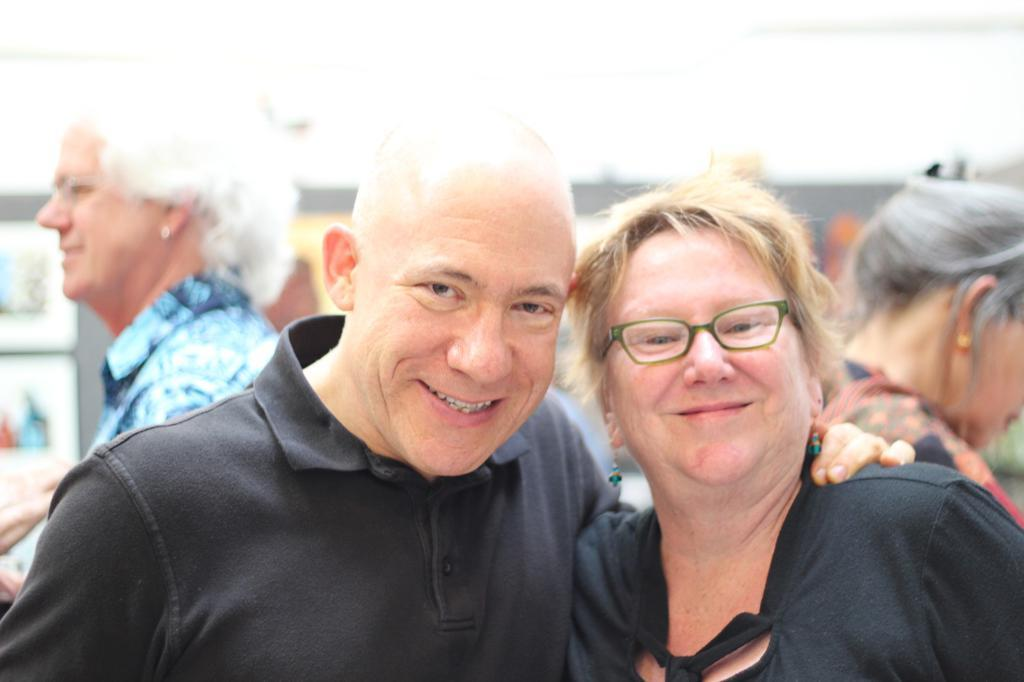How many people are in the image? There are people in the image, but the exact number is not specified. Can you describe any specific features of the people in the image? Yes, a lady on the right side of the image is wearing glasses (specs). What can be said about the background of the image? The background of the image is blurry. What type of base is the lady using to support her request in the image? There is no indication in the image that the lady is making a request or using any type of base for support. 